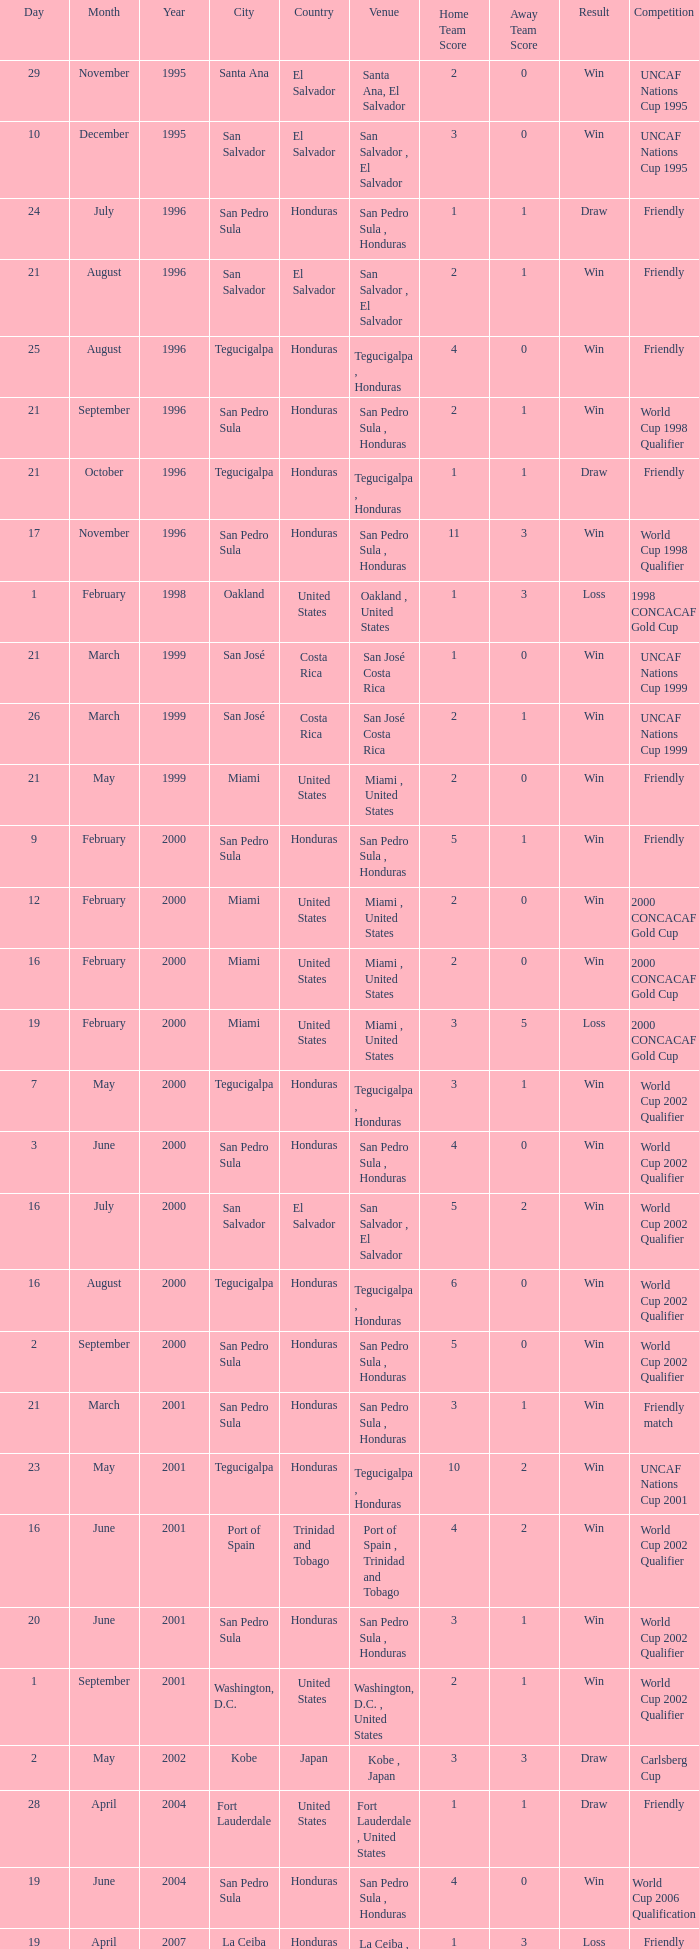Name the score for 7 may 2000 3-1. 